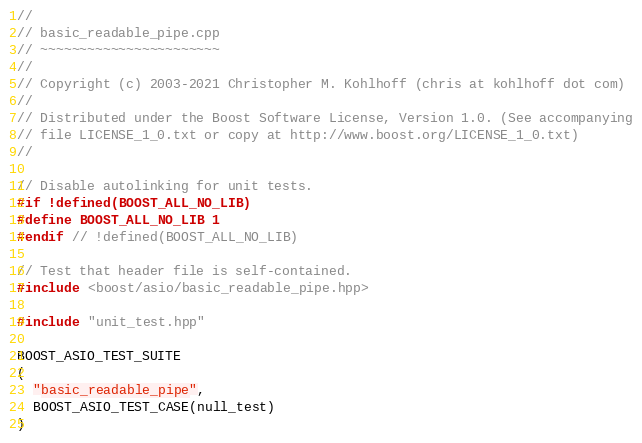<code> <loc_0><loc_0><loc_500><loc_500><_C++_>//
// basic_readable_pipe.cpp
// ~~~~~~~~~~~~~~~~~~~~~~~
//
// Copyright (c) 2003-2021 Christopher M. Kohlhoff (chris at kohlhoff dot com)
//
// Distributed under the Boost Software License, Version 1.0. (See accompanying
// file LICENSE_1_0.txt or copy at http://www.boost.org/LICENSE_1_0.txt)
//

// Disable autolinking for unit tests.
#if !defined(BOOST_ALL_NO_LIB)
#define BOOST_ALL_NO_LIB 1
#endif // !defined(BOOST_ALL_NO_LIB)

// Test that header file is self-contained.
#include <boost/asio/basic_readable_pipe.hpp>

#include "unit_test.hpp"

BOOST_ASIO_TEST_SUITE
(
  "basic_readable_pipe",
  BOOST_ASIO_TEST_CASE(null_test)
)
</code> 